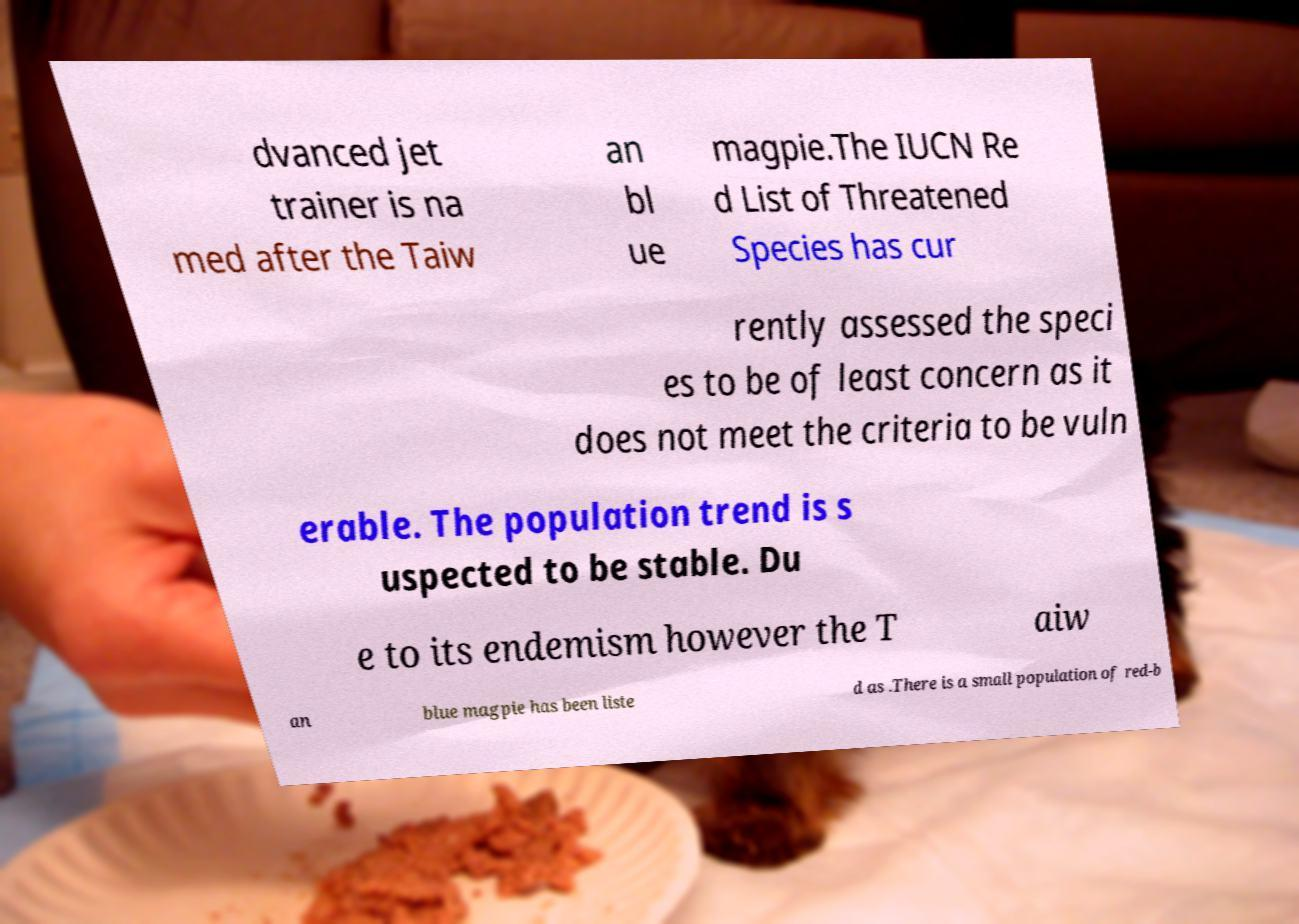Could you extract and type out the text from this image? dvanced jet trainer is na med after the Taiw an bl ue magpie.The IUCN Re d List of Threatened Species has cur rently assessed the speci es to be of least concern as it does not meet the criteria to be vuln erable. The population trend is s uspected to be stable. Du e to its endemism however the T aiw an blue magpie has been liste d as .There is a small population of red-b 